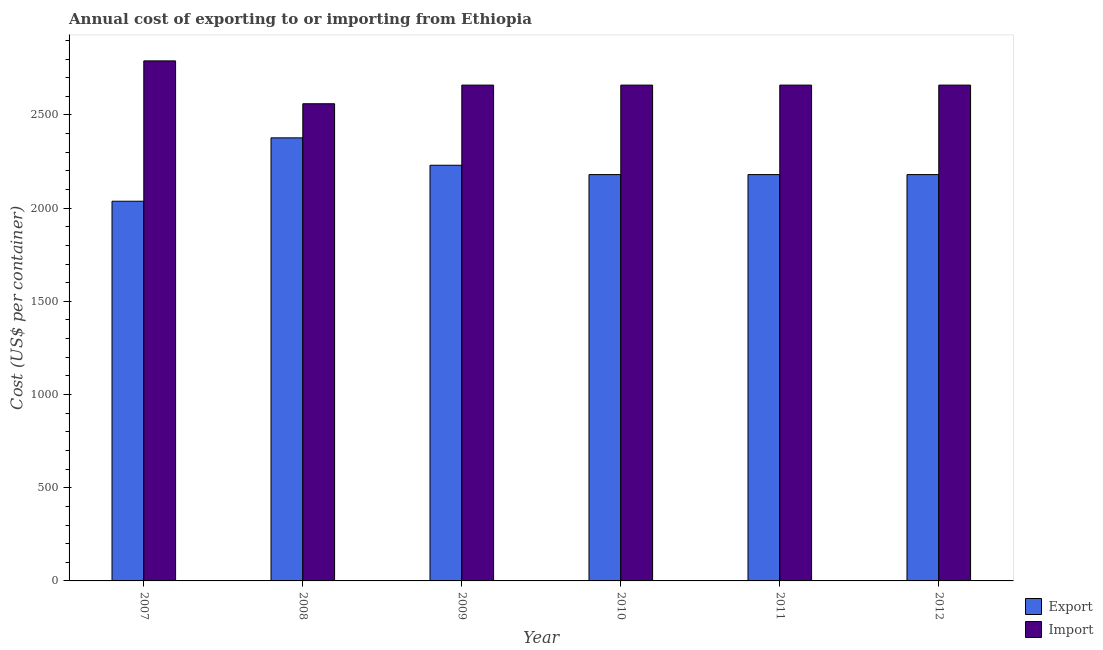How many groups of bars are there?
Provide a succinct answer. 6. Are the number of bars per tick equal to the number of legend labels?
Your answer should be very brief. Yes. How many bars are there on the 4th tick from the left?
Offer a terse response. 2. How many bars are there on the 6th tick from the right?
Your response must be concise. 2. What is the label of the 2nd group of bars from the left?
Your response must be concise. 2008. What is the import cost in 2007?
Offer a very short reply. 2790. Across all years, what is the maximum import cost?
Make the answer very short. 2790. Across all years, what is the minimum import cost?
Offer a very short reply. 2560. What is the total export cost in the graph?
Ensure brevity in your answer.  1.32e+04. What is the difference between the export cost in 2010 and that in 2012?
Your answer should be very brief. 0. What is the difference between the import cost in 2008 and the export cost in 2010?
Your response must be concise. -100. What is the average export cost per year?
Keep it short and to the point. 2197.33. In the year 2007, what is the difference between the import cost and export cost?
Offer a terse response. 0. In how many years, is the export cost greater than 1100 US$?
Ensure brevity in your answer.  6. What is the ratio of the export cost in 2008 to that in 2010?
Provide a succinct answer. 1.09. Is the export cost in 2008 less than that in 2012?
Provide a short and direct response. No. Is the difference between the export cost in 2007 and 2010 greater than the difference between the import cost in 2007 and 2010?
Provide a succinct answer. No. What is the difference between the highest and the second highest export cost?
Offer a very short reply. 147. What is the difference between the highest and the lowest export cost?
Offer a terse response. 340. What does the 1st bar from the left in 2010 represents?
Your answer should be very brief. Export. What does the 1st bar from the right in 2010 represents?
Your answer should be compact. Import. How many bars are there?
Your answer should be very brief. 12. How many years are there in the graph?
Your response must be concise. 6. What is the difference between two consecutive major ticks on the Y-axis?
Give a very brief answer. 500. Are the values on the major ticks of Y-axis written in scientific E-notation?
Your answer should be compact. No. Does the graph contain grids?
Offer a terse response. No. Where does the legend appear in the graph?
Make the answer very short. Bottom right. What is the title of the graph?
Offer a very short reply. Annual cost of exporting to or importing from Ethiopia. Does "Residents" appear as one of the legend labels in the graph?
Your response must be concise. No. What is the label or title of the Y-axis?
Provide a succinct answer. Cost (US$ per container). What is the Cost (US$ per container) in Export in 2007?
Provide a succinct answer. 2037. What is the Cost (US$ per container) in Import in 2007?
Your answer should be compact. 2790. What is the Cost (US$ per container) in Export in 2008?
Your response must be concise. 2377. What is the Cost (US$ per container) of Import in 2008?
Ensure brevity in your answer.  2560. What is the Cost (US$ per container) of Export in 2009?
Your answer should be very brief. 2230. What is the Cost (US$ per container) of Import in 2009?
Offer a terse response. 2660. What is the Cost (US$ per container) of Export in 2010?
Make the answer very short. 2180. What is the Cost (US$ per container) of Import in 2010?
Your response must be concise. 2660. What is the Cost (US$ per container) of Export in 2011?
Make the answer very short. 2180. What is the Cost (US$ per container) of Import in 2011?
Offer a terse response. 2660. What is the Cost (US$ per container) in Export in 2012?
Ensure brevity in your answer.  2180. What is the Cost (US$ per container) in Import in 2012?
Your answer should be compact. 2660. Across all years, what is the maximum Cost (US$ per container) of Export?
Provide a short and direct response. 2377. Across all years, what is the maximum Cost (US$ per container) of Import?
Your answer should be compact. 2790. Across all years, what is the minimum Cost (US$ per container) of Export?
Offer a terse response. 2037. Across all years, what is the minimum Cost (US$ per container) of Import?
Provide a short and direct response. 2560. What is the total Cost (US$ per container) in Export in the graph?
Give a very brief answer. 1.32e+04. What is the total Cost (US$ per container) of Import in the graph?
Your answer should be very brief. 1.60e+04. What is the difference between the Cost (US$ per container) of Export in 2007 and that in 2008?
Your answer should be compact. -340. What is the difference between the Cost (US$ per container) in Import in 2007 and that in 2008?
Offer a terse response. 230. What is the difference between the Cost (US$ per container) of Export in 2007 and that in 2009?
Offer a very short reply. -193. What is the difference between the Cost (US$ per container) in Import in 2007 and that in 2009?
Your answer should be compact. 130. What is the difference between the Cost (US$ per container) of Export in 2007 and that in 2010?
Provide a short and direct response. -143. What is the difference between the Cost (US$ per container) in Import in 2007 and that in 2010?
Ensure brevity in your answer.  130. What is the difference between the Cost (US$ per container) of Export in 2007 and that in 2011?
Make the answer very short. -143. What is the difference between the Cost (US$ per container) in Import in 2007 and that in 2011?
Give a very brief answer. 130. What is the difference between the Cost (US$ per container) of Export in 2007 and that in 2012?
Offer a very short reply. -143. What is the difference between the Cost (US$ per container) in Import in 2007 and that in 2012?
Provide a succinct answer. 130. What is the difference between the Cost (US$ per container) of Export in 2008 and that in 2009?
Your answer should be compact. 147. What is the difference between the Cost (US$ per container) in Import in 2008 and that in 2009?
Make the answer very short. -100. What is the difference between the Cost (US$ per container) in Export in 2008 and that in 2010?
Your response must be concise. 197. What is the difference between the Cost (US$ per container) of Import in 2008 and that in 2010?
Your response must be concise. -100. What is the difference between the Cost (US$ per container) in Export in 2008 and that in 2011?
Your answer should be very brief. 197. What is the difference between the Cost (US$ per container) in Import in 2008 and that in 2011?
Your response must be concise. -100. What is the difference between the Cost (US$ per container) in Export in 2008 and that in 2012?
Your response must be concise. 197. What is the difference between the Cost (US$ per container) in Import in 2008 and that in 2012?
Ensure brevity in your answer.  -100. What is the difference between the Cost (US$ per container) in Import in 2009 and that in 2010?
Offer a very short reply. 0. What is the difference between the Cost (US$ per container) in Import in 2009 and that in 2011?
Keep it short and to the point. 0. What is the difference between the Cost (US$ per container) in Export in 2010 and that in 2012?
Offer a very short reply. 0. What is the difference between the Cost (US$ per container) of Import in 2010 and that in 2012?
Your answer should be very brief. 0. What is the difference between the Cost (US$ per container) of Export in 2011 and that in 2012?
Give a very brief answer. 0. What is the difference between the Cost (US$ per container) of Import in 2011 and that in 2012?
Give a very brief answer. 0. What is the difference between the Cost (US$ per container) in Export in 2007 and the Cost (US$ per container) in Import in 2008?
Your response must be concise. -523. What is the difference between the Cost (US$ per container) in Export in 2007 and the Cost (US$ per container) in Import in 2009?
Keep it short and to the point. -623. What is the difference between the Cost (US$ per container) of Export in 2007 and the Cost (US$ per container) of Import in 2010?
Your answer should be compact. -623. What is the difference between the Cost (US$ per container) of Export in 2007 and the Cost (US$ per container) of Import in 2011?
Provide a succinct answer. -623. What is the difference between the Cost (US$ per container) in Export in 2007 and the Cost (US$ per container) in Import in 2012?
Keep it short and to the point. -623. What is the difference between the Cost (US$ per container) of Export in 2008 and the Cost (US$ per container) of Import in 2009?
Your response must be concise. -283. What is the difference between the Cost (US$ per container) in Export in 2008 and the Cost (US$ per container) in Import in 2010?
Offer a very short reply. -283. What is the difference between the Cost (US$ per container) of Export in 2008 and the Cost (US$ per container) of Import in 2011?
Make the answer very short. -283. What is the difference between the Cost (US$ per container) in Export in 2008 and the Cost (US$ per container) in Import in 2012?
Provide a succinct answer. -283. What is the difference between the Cost (US$ per container) in Export in 2009 and the Cost (US$ per container) in Import in 2010?
Your answer should be very brief. -430. What is the difference between the Cost (US$ per container) in Export in 2009 and the Cost (US$ per container) in Import in 2011?
Make the answer very short. -430. What is the difference between the Cost (US$ per container) of Export in 2009 and the Cost (US$ per container) of Import in 2012?
Provide a succinct answer. -430. What is the difference between the Cost (US$ per container) in Export in 2010 and the Cost (US$ per container) in Import in 2011?
Your answer should be very brief. -480. What is the difference between the Cost (US$ per container) in Export in 2010 and the Cost (US$ per container) in Import in 2012?
Your answer should be compact. -480. What is the difference between the Cost (US$ per container) in Export in 2011 and the Cost (US$ per container) in Import in 2012?
Give a very brief answer. -480. What is the average Cost (US$ per container) of Export per year?
Your answer should be very brief. 2197.33. What is the average Cost (US$ per container) in Import per year?
Ensure brevity in your answer.  2665. In the year 2007, what is the difference between the Cost (US$ per container) of Export and Cost (US$ per container) of Import?
Your answer should be very brief. -753. In the year 2008, what is the difference between the Cost (US$ per container) of Export and Cost (US$ per container) of Import?
Give a very brief answer. -183. In the year 2009, what is the difference between the Cost (US$ per container) of Export and Cost (US$ per container) of Import?
Offer a very short reply. -430. In the year 2010, what is the difference between the Cost (US$ per container) of Export and Cost (US$ per container) of Import?
Offer a very short reply. -480. In the year 2011, what is the difference between the Cost (US$ per container) in Export and Cost (US$ per container) in Import?
Provide a succinct answer. -480. In the year 2012, what is the difference between the Cost (US$ per container) in Export and Cost (US$ per container) in Import?
Provide a succinct answer. -480. What is the ratio of the Cost (US$ per container) of Export in 2007 to that in 2008?
Offer a very short reply. 0.86. What is the ratio of the Cost (US$ per container) of Import in 2007 to that in 2008?
Offer a terse response. 1.09. What is the ratio of the Cost (US$ per container) in Export in 2007 to that in 2009?
Your response must be concise. 0.91. What is the ratio of the Cost (US$ per container) in Import in 2007 to that in 2009?
Offer a very short reply. 1.05. What is the ratio of the Cost (US$ per container) of Export in 2007 to that in 2010?
Your answer should be very brief. 0.93. What is the ratio of the Cost (US$ per container) in Import in 2007 to that in 2010?
Provide a short and direct response. 1.05. What is the ratio of the Cost (US$ per container) of Export in 2007 to that in 2011?
Make the answer very short. 0.93. What is the ratio of the Cost (US$ per container) in Import in 2007 to that in 2011?
Keep it short and to the point. 1.05. What is the ratio of the Cost (US$ per container) in Export in 2007 to that in 2012?
Make the answer very short. 0.93. What is the ratio of the Cost (US$ per container) of Import in 2007 to that in 2012?
Provide a short and direct response. 1.05. What is the ratio of the Cost (US$ per container) in Export in 2008 to that in 2009?
Give a very brief answer. 1.07. What is the ratio of the Cost (US$ per container) of Import in 2008 to that in 2009?
Give a very brief answer. 0.96. What is the ratio of the Cost (US$ per container) of Export in 2008 to that in 2010?
Your response must be concise. 1.09. What is the ratio of the Cost (US$ per container) in Import in 2008 to that in 2010?
Keep it short and to the point. 0.96. What is the ratio of the Cost (US$ per container) in Export in 2008 to that in 2011?
Give a very brief answer. 1.09. What is the ratio of the Cost (US$ per container) of Import in 2008 to that in 2011?
Your response must be concise. 0.96. What is the ratio of the Cost (US$ per container) in Export in 2008 to that in 2012?
Offer a terse response. 1.09. What is the ratio of the Cost (US$ per container) in Import in 2008 to that in 2012?
Make the answer very short. 0.96. What is the ratio of the Cost (US$ per container) of Export in 2009 to that in 2010?
Provide a succinct answer. 1.02. What is the ratio of the Cost (US$ per container) in Import in 2009 to that in 2010?
Provide a succinct answer. 1. What is the ratio of the Cost (US$ per container) of Export in 2009 to that in 2011?
Offer a very short reply. 1.02. What is the ratio of the Cost (US$ per container) in Export in 2009 to that in 2012?
Your response must be concise. 1.02. What is the ratio of the Cost (US$ per container) of Import in 2010 to that in 2011?
Offer a very short reply. 1. What is the ratio of the Cost (US$ per container) in Export in 2010 to that in 2012?
Ensure brevity in your answer.  1. What is the ratio of the Cost (US$ per container) in Import in 2010 to that in 2012?
Your answer should be very brief. 1. What is the ratio of the Cost (US$ per container) of Import in 2011 to that in 2012?
Provide a succinct answer. 1. What is the difference between the highest and the second highest Cost (US$ per container) of Export?
Your answer should be compact. 147. What is the difference between the highest and the second highest Cost (US$ per container) in Import?
Offer a very short reply. 130. What is the difference between the highest and the lowest Cost (US$ per container) of Export?
Ensure brevity in your answer.  340. What is the difference between the highest and the lowest Cost (US$ per container) of Import?
Your answer should be compact. 230. 